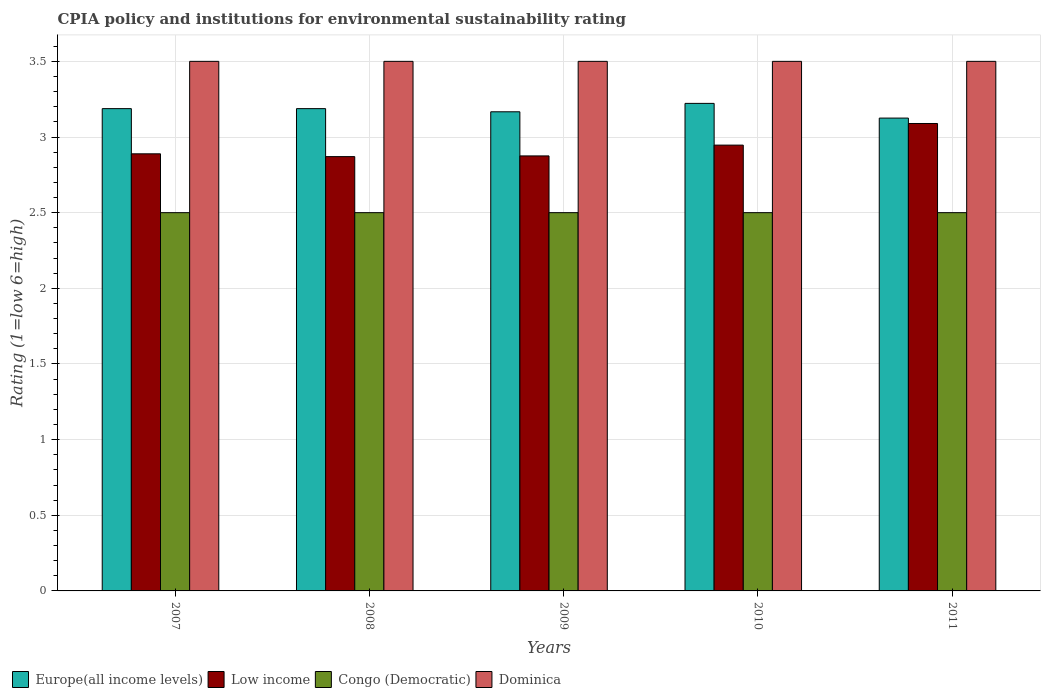How many different coloured bars are there?
Your answer should be very brief. 4. How many bars are there on the 2nd tick from the left?
Keep it short and to the point. 4. Across all years, what is the maximum CPIA rating in Low income?
Make the answer very short. 3.09. Across all years, what is the minimum CPIA rating in Europe(all income levels)?
Your answer should be very brief. 3.12. In which year was the CPIA rating in Europe(all income levels) maximum?
Make the answer very short. 2010. What is the total CPIA rating in Low income in the graph?
Make the answer very short. 14.67. What is the difference between the CPIA rating in Low income in 2007 and that in 2008?
Keep it short and to the point. 0.02. What is the difference between the CPIA rating in Europe(all income levels) in 2008 and the CPIA rating in Congo (Democratic) in 2010?
Your response must be concise. 0.69. What is the average CPIA rating in Congo (Democratic) per year?
Provide a succinct answer. 2.5. In the year 2009, what is the difference between the CPIA rating in Europe(all income levels) and CPIA rating in Dominica?
Give a very brief answer. -0.33. In how many years, is the CPIA rating in Congo (Democratic) greater than 0.6?
Offer a very short reply. 5. What is the ratio of the CPIA rating in Low income in 2008 to that in 2010?
Provide a succinct answer. 0.97. Is the difference between the CPIA rating in Europe(all income levels) in 2010 and 2011 greater than the difference between the CPIA rating in Dominica in 2010 and 2011?
Provide a short and direct response. Yes. What is the difference between the highest and the second highest CPIA rating in Congo (Democratic)?
Offer a very short reply. 0. In how many years, is the CPIA rating in Low income greater than the average CPIA rating in Low income taken over all years?
Give a very brief answer. 2. Is it the case that in every year, the sum of the CPIA rating in Congo (Democratic) and CPIA rating in Dominica is greater than the sum of CPIA rating in Europe(all income levels) and CPIA rating in Low income?
Your answer should be compact. No. What does the 1st bar from the left in 2007 represents?
Keep it short and to the point. Europe(all income levels). What does the 1st bar from the right in 2007 represents?
Provide a short and direct response. Dominica. How many years are there in the graph?
Make the answer very short. 5. What is the difference between two consecutive major ticks on the Y-axis?
Keep it short and to the point. 0.5. Does the graph contain grids?
Your answer should be very brief. Yes. Where does the legend appear in the graph?
Keep it short and to the point. Bottom left. How many legend labels are there?
Give a very brief answer. 4. What is the title of the graph?
Make the answer very short. CPIA policy and institutions for environmental sustainability rating. Does "Sierra Leone" appear as one of the legend labels in the graph?
Your answer should be compact. No. What is the label or title of the X-axis?
Offer a terse response. Years. What is the label or title of the Y-axis?
Give a very brief answer. Rating (1=low 6=high). What is the Rating (1=low 6=high) in Europe(all income levels) in 2007?
Keep it short and to the point. 3.19. What is the Rating (1=low 6=high) of Low income in 2007?
Your response must be concise. 2.89. What is the Rating (1=low 6=high) of Congo (Democratic) in 2007?
Provide a succinct answer. 2.5. What is the Rating (1=low 6=high) in Europe(all income levels) in 2008?
Ensure brevity in your answer.  3.19. What is the Rating (1=low 6=high) of Low income in 2008?
Make the answer very short. 2.87. What is the Rating (1=low 6=high) in Congo (Democratic) in 2008?
Your answer should be very brief. 2.5. What is the Rating (1=low 6=high) of Europe(all income levels) in 2009?
Provide a short and direct response. 3.17. What is the Rating (1=low 6=high) in Low income in 2009?
Give a very brief answer. 2.88. What is the Rating (1=low 6=high) in Dominica in 2009?
Your response must be concise. 3.5. What is the Rating (1=low 6=high) in Europe(all income levels) in 2010?
Your response must be concise. 3.22. What is the Rating (1=low 6=high) of Low income in 2010?
Your response must be concise. 2.95. What is the Rating (1=low 6=high) in Europe(all income levels) in 2011?
Make the answer very short. 3.12. What is the Rating (1=low 6=high) in Low income in 2011?
Give a very brief answer. 3.09. Across all years, what is the maximum Rating (1=low 6=high) of Europe(all income levels)?
Give a very brief answer. 3.22. Across all years, what is the maximum Rating (1=low 6=high) of Low income?
Keep it short and to the point. 3.09. Across all years, what is the maximum Rating (1=low 6=high) of Congo (Democratic)?
Make the answer very short. 2.5. Across all years, what is the minimum Rating (1=low 6=high) of Europe(all income levels)?
Your response must be concise. 3.12. Across all years, what is the minimum Rating (1=low 6=high) of Low income?
Your answer should be very brief. 2.87. Across all years, what is the minimum Rating (1=low 6=high) of Congo (Democratic)?
Your answer should be compact. 2.5. Across all years, what is the minimum Rating (1=low 6=high) in Dominica?
Provide a short and direct response. 3.5. What is the total Rating (1=low 6=high) in Europe(all income levels) in the graph?
Offer a terse response. 15.89. What is the total Rating (1=low 6=high) in Low income in the graph?
Your answer should be compact. 14.67. What is the difference between the Rating (1=low 6=high) in Low income in 2007 and that in 2008?
Provide a succinct answer. 0.02. What is the difference between the Rating (1=low 6=high) in Europe(all income levels) in 2007 and that in 2009?
Ensure brevity in your answer.  0.02. What is the difference between the Rating (1=low 6=high) of Low income in 2007 and that in 2009?
Your answer should be compact. 0.01. What is the difference between the Rating (1=low 6=high) in Congo (Democratic) in 2007 and that in 2009?
Ensure brevity in your answer.  0. What is the difference between the Rating (1=low 6=high) of Europe(all income levels) in 2007 and that in 2010?
Give a very brief answer. -0.03. What is the difference between the Rating (1=low 6=high) in Low income in 2007 and that in 2010?
Offer a very short reply. -0.06. What is the difference between the Rating (1=low 6=high) in Dominica in 2007 and that in 2010?
Offer a very short reply. 0. What is the difference between the Rating (1=low 6=high) of Europe(all income levels) in 2007 and that in 2011?
Offer a terse response. 0.06. What is the difference between the Rating (1=low 6=high) in Low income in 2007 and that in 2011?
Your answer should be very brief. -0.2. What is the difference between the Rating (1=low 6=high) of Europe(all income levels) in 2008 and that in 2009?
Provide a short and direct response. 0.02. What is the difference between the Rating (1=low 6=high) in Low income in 2008 and that in 2009?
Provide a succinct answer. -0. What is the difference between the Rating (1=low 6=high) in Dominica in 2008 and that in 2009?
Provide a succinct answer. 0. What is the difference between the Rating (1=low 6=high) of Europe(all income levels) in 2008 and that in 2010?
Keep it short and to the point. -0.03. What is the difference between the Rating (1=low 6=high) in Low income in 2008 and that in 2010?
Keep it short and to the point. -0.08. What is the difference between the Rating (1=low 6=high) of Congo (Democratic) in 2008 and that in 2010?
Give a very brief answer. 0. What is the difference between the Rating (1=low 6=high) of Dominica in 2008 and that in 2010?
Make the answer very short. 0. What is the difference between the Rating (1=low 6=high) in Europe(all income levels) in 2008 and that in 2011?
Ensure brevity in your answer.  0.06. What is the difference between the Rating (1=low 6=high) in Low income in 2008 and that in 2011?
Provide a succinct answer. -0.22. What is the difference between the Rating (1=low 6=high) in Dominica in 2008 and that in 2011?
Your answer should be compact. 0. What is the difference between the Rating (1=low 6=high) of Europe(all income levels) in 2009 and that in 2010?
Your answer should be very brief. -0.06. What is the difference between the Rating (1=low 6=high) of Low income in 2009 and that in 2010?
Offer a very short reply. -0.07. What is the difference between the Rating (1=low 6=high) in Europe(all income levels) in 2009 and that in 2011?
Your answer should be compact. 0.04. What is the difference between the Rating (1=low 6=high) of Low income in 2009 and that in 2011?
Give a very brief answer. -0.21. What is the difference between the Rating (1=low 6=high) of Dominica in 2009 and that in 2011?
Make the answer very short. 0. What is the difference between the Rating (1=low 6=high) of Europe(all income levels) in 2010 and that in 2011?
Ensure brevity in your answer.  0.1. What is the difference between the Rating (1=low 6=high) in Low income in 2010 and that in 2011?
Keep it short and to the point. -0.14. What is the difference between the Rating (1=low 6=high) in Congo (Democratic) in 2010 and that in 2011?
Keep it short and to the point. 0. What is the difference between the Rating (1=low 6=high) of Dominica in 2010 and that in 2011?
Provide a short and direct response. 0. What is the difference between the Rating (1=low 6=high) in Europe(all income levels) in 2007 and the Rating (1=low 6=high) in Low income in 2008?
Provide a short and direct response. 0.32. What is the difference between the Rating (1=low 6=high) in Europe(all income levels) in 2007 and the Rating (1=low 6=high) in Congo (Democratic) in 2008?
Offer a very short reply. 0.69. What is the difference between the Rating (1=low 6=high) of Europe(all income levels) in 2007 and the Rating (1=low 6=high) of Dominica in 2008?
Your response must be concise. -0.31. What is the difference between the Rating (1=low 6=high) of Low income in 2007 and the Rating (1=low 6=high) of Congo (Democratic) in 2008?
Your answer should be very brief. 0.39. What is the difference between the Rating (1=low 6=high) of Low income in 2007 and the Rating (1=low 6=high) of Dominica in 2008?
Your response must be concise. -0.61. What is the difference between the Rating (1=low 6=high) in Europe(all income levels) in 2007 and the Rating (1=low 6=high) in Low income in 2009?
Provide a succinct answer. 0.31. What is the difference between the Rating (1=low 6=high) in Europe(all income levels) in 2007 and the Rating (1=low 6=high) in Congo (Democratic) in 2009?
Your answer should be very brief. 0.69. What is the difference between the Rating (1=low 6=high) in Europe(all income levels) in 2007 and the Rating (1=low 6=high) in Dominica in 2009?
Your answer should be compact. -0.31. What is the difference between the Rating (1=low 6=high) of Low income in 2007 and the Rating (1=low 6=high) of Congo (Democratic) in 2009?
Provide a succinct answer. 0.39. What is the difference between the Rating (1=low 6=high) in Low income in 2007 and the Rating (1=low 6=high) in Dominica in 2009?
Ensure brevity in your answer.  -0.61. What is the difference between the Rating (1=low 6=high) in Congo (Democratic) in 2007 and the Rating (1=low 6=high) in Dominica in 2009?
Give a very brief answer. -1. What is the difference between the Rating (1=low 6=high) of Europe(all income levels) in 2007 and the Rating (1=low 6=high) of Low income in 2010?
Offer a very short reply. 0.24. What is the difference between the Rating (1=low 6=high) of Europe(all income levels) in 2007 and the Rating (1=low 6=high) of Congo (Democratic) in 2010?
Ensure brevity in your answer.  0.69. What is the difference between the Rating (1=low 6=high) in Europe(all income levels) in 2007 and the Rating (1=low 6=high) in Dominica in 2010?
Ensure brevity in your answer.  -0.31. What is the difference between the Rating (1=low 6=high) in Low income in 2007 and the Rating (1=low 6=high) in Congo (Democratic) in 2010?
Offer a very short reply. 0.39. What is the difference between the Rating (1=low 6=high) of Low income in 2007 and the Rating (1=low 6=high) of Dominica in 2010?
Offer a terse response. -0.61. What is the difference between the Rating (1=low 6=high) in Europe(all income levels) in 2007 and the Rating (1=low 6=high) in Low income in 2011?
Give a very brief answer. 0.1. What is the difference between the Rating (1=low 6=high) of Europe(all income levels) in 2007 and the Rating (1=low 6=high) of Congo (Democratic) in 2011?
Provide a short and direct response. 0.69. What is the difference between the Rating (1=low 6=high) of Europe(all income levels) in 2007 and the Rating (1=low 6=high) of Dominica in 2011?
Give a very brief answer. -0.31. What is the difference between the Rating (1=low 6=high) of Low income in 2007 and the Rating (1=low 6=high) of Congo (Democratic) in 2011?
Your answer should be compact. 0.39. What is the difference between the Rating (1=low 6=high) of Low income in 2007 and the Rating (1=low 6=high) of Dominica in 2011?
Provide a succinct answer. -0.61. What is the difference between the Rating (1=low 6=high) in Europe(all income levels) in 2008 and the Rating (1=low 6=high) in Low income in 2009?
Offer a terse response. 0.31. What is the difference between the Rating (1=low 6=high) of Europe(all income levels) in 2008 and the Rating (1=low 6=high) of Congo (Democratic) in 2009?
Offer a terse response. 0.69. What is the difference between the Rating (1=low 6=high) in Europe(all income levels) in 2008 and the Rating (1=low 6=high) in Dominica in 2009?
Your response must be concise. -0.31. What is the difference between the Rating (1=low 6=high) in Low income in 2008 and the Rating (1=low 6=high) in Congo (Democratic) in 2009?
Ensure brevity in your answer.  0.37. What is the difference between the Rating (1=low 6=high) in Low income in 2008 and the Rating (1=low 6=high) in Dominica in 2009?
Offer a very short reply. -0.63. What is the difference between the Rating (1=low 6=high) in Congo (Democratic) in 2008 and the Rating (1=low 6=high) in Dominica in 2009?
Give a very brief answer. -1. What is the difference between the Rating (1=low 6=high) in Europe(all income levels) in 2008 and the Rating (1=low 6=high) in Low income in 2010?
Offer a terse response. 0.24. What is the difference between the Rating (1=low 6=high) in Europe(all income levels) in 2008 and the Rating (1=low 6=high) in Congo (Democratic) in 2010?
Your answer should be very brief. 0.69. What is the difference between the Rating (1=low 6=high) in Europe(all income levels) in 2008 and the Rating (1=low 6=high) in Dominica in 2010?
Give a very brief answer. -0.31. What is the difference between the Rating (1=low 6=high) in Low income in 2008 and the Rating (1=low 6=high) in Congo (Democratic) in 2010?
Your answer should be compact. 0.37. What is the difference between the Rating (1=low 6=high) in Low income in 2008 and the Rating (1=low 6=high) in Dominica in 2010?
Make the answer very short. -0.63. What is the difference between the Rating (1=low 6=high) of Congo (Democratic) in 2008 and the Rating (1=low 6=high) of Dominica in 2010?
Make the answer very short. -1. What is the difference between the Rating (1=low 6=high) of Europe(all income levels) in 2008 and the Rating (1=low 6=high) of Low income in 2011?
Your response must be concise. 0.1. What is the difference between the Rating (1=low 6=high) of Europe(all income levels) in 2008 and the Rating (1=low 6=high) of Congo (Democratic) in 2011?
Your response must be concise. 0.69. What is the difference between the Rating (1=low 6=high) in Europe(all income levels) in 2008 and the Rating (1=low 6=high) in Dominica in 2011?
Offer a terse response. -0.31. What is the difference between the Rating (1=low 6=high) of Low income in 2008 and the Rating (1=low 6=high) of Congo (Democratic) in 2011?
Offer a terse response. 0.37. What is the difference between the Rating (1=low 6=high) of Low income in 2008 and the Rating (1=low 6=high) of Dominica in 2011?
Your response must be concise. -0.63. What is the difference between the Rating (1=low 6=high) of Congo (Democratic) in 2008 and the Rating (1=low 6=high) of Dominica in 2011?
Your answer should be very brief. -1. What is the difference between the Rating (1=low 6=high) in Europe(all income levels) in 2009 and the Rating (1=low 6=high) in Low income in 2010?
Your response must be concise. 0.22. What is the difference between the Rating (1=low 6=high) in Europe(all income levels) in 2009 and the Rating (1=low 6=high) in Congo (Democratic) in 2010?
Provide a succinct answer. 0.67. What is the difference between the Rating (1=low 6=high) in Europe(all income levels) in 2009 and the Rating (1=low 6=high) in Dominica in 2010?
Your response must be concise. -0.33. What is the difference between the Rating (1=low 6=high) in Low income in 2009 and the Rating (1=low 6=high) in Dominica in 2010?
Ensure brevity in your answer.  -0.62. What is the difference between the Rating (1=low 6=high) in Europe(all income levels) in 2009 and the Rating (1=low 6=high) in Low income in 2011?
Offer a very short reply. 0.08. What is the difference between the Rating (1=low 6=high) of Europe(all income levels) in 2009 and the Rating (1=low 6=high) of Dominica in 2011?
Give a very brief answer. -0.33. What is the difference between the Rating (1=low 6=high) in Low income in 2009 and the Rating (1=low 6=high) in Congo (Democratic) in 2011?
Give a very brief answer. 0.38. What is the difference between the Rating (1=low 6=high) in Low income in 2009 and the Rating (1=low 6=high) in Dominica in 2011?
Your answer should be very brief. -0.62. What is the difference between the Rating (1=low 6=high) of Europe(all income levels) in 2010 and the Rating (1=low 6=high) of Low income in 2011?
Offer a very short reply. 0.13. What is the difference between the Rating (1=low 6=high) of Europe(all income levels) in 2010 and the Rating (1=low 6=high) of Congo (Democratic) in 2011?
Keep it short and to the point. 0.72. What is the difference between the Rating (1=low 6=high) of Europe(all income levels) in 2010 and the Rating (1=low 6=high) of Dominica in 2011?
Your response must be concise. -0.28. What is the difference between the Rating (1=low 6=high) of Low income in 2010 and the Rating (1=low 6=high) of Congo (Democratic) in 2011?
Your answer should be very brief. 0.45. What is the difference between the Rating (1=low 6=high) of Low income in 2010 and the Rating (1=low 6=high) of Dominica in 2011?
Your answer should be compact. -0.55. What is the average Rating (1=low 6=high) in Europe(all income levels) per year?
Offer a very short reply. 3.18. What is the average Rating (1=low 6=high) in Low income per year?
Your response must be concise. 2.93. In the year 2007, what is the difference between the Rating (1=low 6=high) in Europe(all income levels) and Rating (1=low 6=high) in Low income?
Provide a short and direct response. 0.3. In the year 2007, what is the difference between the Rating (1=low 6=high) in Europe(all income levels) and Rating (1=low 6=high) in Congo (Democratic)?
Your response must be concise. 0.69. In the year 2007, what is the difference between the Rating (1=low 6=high) of Europe(all income levels) and Rating (1=low 6=high) of Dominica?
Your answer should be compact. -0.31. In the year 2007, what is the difference between the Rating (1=low 6=high) of Low income and Rating (1=low 6=high) of Congo (Democratic)?
Ensure brevity in your answer.  0.39. In the year 2007, what is the difference between the Rating (1=low 6=high) of Low income and Rating (1=low 6=high) of Dominica?
Make the answer very short. -0.61. In the year 2007, what is the difference between the Rating (1=low 6=high) of Congo (Democratic) and Rating (1=low 6=high) of Dominica?
Offer a very short reply. -1. In the year 2008, what is the difference between the Rating (1=low 6=high) in Europe(all income levels) and Rating (1=low 6=high) in Low income?
Provide a succinct answer. 0.32. In the year 2008, what is the difference between the Rating (1=low 6=high) in Europe(all income levels) and Rating (1=low 6=high) in Congo (Democratic)?
Your answer should be compact. 0.69. In the year 2008, what is the difference between the Rating (1=low 6=high) of Europe(all income levels) and Rating (1=low 6=high) of Dominica?
Your answer should be very brief. -0.31. In the year 2008, what is the difference between the Rating (1=low 6=high) in Low income and Rating (1=low 6=high) in Congo (Democratic)?
Ensure brevity in your answer.  0.37. In the year 2008, what is the difference between the Rating (1=low 6=high) of Low income and Rating (1=low 6=high) of Dominica?
Your answer should be compact. -0.63. In the year 2008, what is the difference between the Rating (1=low 6=high) of Congo (Democratic) and Rating (1=low 6=high) of Dominica?
Offer a terse response. -1. In the year 2009, what is the difference between the Rating (1=low 6=high) of Europe(all income levels) and Rating (1=low 6=high) of Low income?
Keep it short and to the point. 0.29. In the year 2009, what is the difference between the Rating (1=low 6=high) of Europe(all income levels) and Rating (1=low 6=high) of Congo (Democratic)?
Keep it short and to the point. 0.67. In the year 2009, what is the difference between the Rating (1=low 6=high) of Europe(all income levels) and Rating (1=low 6=high) of Dominica?
Offer a very short reply. -0.33. In the year 2009, what is the difference between the Rating (1=low 6=high) in Low income and Rating (1=low 6=high) in Dominica?
Your answer should be compact. -0.62. In the year 2009, what is the difference between the Rating (1=low 6=high) in Congo (Democratic) and Rating (1=low 6=high) in Dominica?
Your answer should be compact. -1. In the year 2010, what is the difference between the Rating (1=low 6=high) in Europe(all income levels) and Rating (1=low 6=high) in Low income?
Offer a terse response. 0.28. In the year 2010, what is the difference between the Rating (1=low 6=high) of Europe(all income levels) and Rating (1=low 6=high) of Congo (Democratic)?
Your answer should be very brief. 0.72. In the year 2010, what is the difference between the Rating (1=low 6=high) of Europe(all income levels) and Rating (1=low 6=high) of Dominica?
Make the answer very short. -0.28. In the year 2010, what is the difference between the Rating (1=low 6=high) in Low income and Rating (1=low 6=high) in Congo (Democratic)?
Keep it short and to the point. 0.45. In the year 2010, what is the difference between the Rating (1=low 6=high) in Low income and Rating (1=low 6=high) in Dominica?
Provide a short and direct response. -0.55. In the year 2011, what is the difference between the Rating (1=low 6=high) of Europe(all income levels) and Rating (1=low 6=high) of Low income?
Keep it short and to the point. 0.04. In the year 2011, what is the difference between the Rating (1=low 6=high) in Europe(all income levels) and Rating (1=low 6=high) in Dominica?
Provide a succinct answer. -0.38. In the year 2011, what is the difference between the Rating (1=low 6=high) of Low income and Rating (1=low 6=high) of Congo (Democratic)?
Your answer should be compact. 0.59. In the year 2011, what is the difference between the Rating (1=low 6=high) of Low income and Rating (1=low 6=high) of Dominica?
Make the answer very short. -0.41. In the year 2011, what is the difference between the Rating (1=low 6=high) of Congo (Democratic) and Rating (1=low 6=high) of Dominica?
Provide a short and direct response. -1. What is the ratio of the Rating (1=low 6=high) of Europe(all income levels) in 2007 to that in 2008?
Offer a terse response. 1. What is the ratio of the Rating (1=low 6=high) in Low income in 2007 to that in 2008?
Make the answer very short. 1.01. What is the ratio of the Rating (1=low 6=high) in Congo (Democratic) in 2007 to that in 2008?
Keep it short and to the point. 1. What is the ratio of the Rating (1=low 6=high) in Dominica in 2007 to that in 2008?
Give a very brief answer. 1. What is the ratio of the Rating (1=low 6=high) of Europe(all income levels) in 2007 to that in 2009?
Offer a very short reply. 1.01. What is the ratio of the Rating (1=low 6=high) in Low income in 2007 to that in 2009?
Offer a very short reply. 1. What is the ratio of the Rating (1=low 6=high) in Congo (Democratic) in 2007 to that in 2009?
Give a very brief answer. 1. What is the ratio of the Rating (1=low 6=high) of Europe(all income levels) in 2007 to that in 2010?
Give a very brief answer. 0.99. What is the ratio of the Rating (1=low 6=high) of Low income in 2007 to that in 2010?
Your answer should be compact. 0.98. What is the ratio of the Rating (1=low 6=high) in Congo (Democratic) in 2007 to that in 2010?
Your answer should be compact. 1. What is the ratio of the Rating (1=low 6=high) in Low income in 2007 to that in 2011?
Offer a very short reply. 0.94. What is the ratio of the Rating (1=low 6=high) in Europe(all income levels) in 2008 to that in 2009?
Provide a succinct answer. 1.01. What is the ratio of the Rating (1=low 6=high) in Congo (Democratic) in 2008 to that in 2009?
Your answer should be very brief. 1. What is the ratio of the Rating (1=low 6=high) of Europe(all income levels) in 2008 to that in 2010?
Ensure brevity in your answer.  0.99. What is the ratio of the Rating (1=low 6=high) of Low income in 2008 to that in 2010?
Give a very brief answer. 0.97. What is the ratio of the Rating (1=low 6=high) in Dominica in 2008 to that in 2010?
Ensure brevity in your answer.  1. What is the ratio of the Rating (1=low 6=high) in Low income in 2008 to that in 2011?
Ensure brevity in your answer.  0.93. What is the ratio of the Rating (1=low 6=high) of Congo (Democratic) in 2008 to that in 2011?
Keep it short and to the point. 1. What is the ratio of the Rating (1=low 6=high) of Europe(all income levels) in 2009 to that in 2010?
Your answer should be compact. 0.98. What is the ratio of the Rating (1=low 6=high) of Low income in 2009 to that in 2010?
Your response must be concise. 0.98. What is the ratio of the Rating (1=low 6=high) of Europe(all income levels) in 2009 to that in 2011?
Ensure brevity in your answer.  1.01. What is the ratio of the Rating (1=low 6=high) of Low income in 2009 to that in 2011?
Offer a very short reply. 0.93. What is the ratio of the Rating (1=low 6=high) in Congo (Democratic) in 2009 to that in 2011?
Your answer should be compact. 1. What is the ratio of the Rating (1=low 6=high) in Dominica in 2009 to that in 2011?
Your answer should be compact. 1. What is the ratio of the Rating (1=low 6=high) of Europe(all income levels) in 2010 to that in 2011?
Make the answer very short. 1.03. What is the ratio of the Rating (1=low 6=high) of Low income in 2010 to that in 2011?
Provide a succinct answer. 0.95. What is the ratio of the Rating (1=low 6=high) of Congo (Democratic) in 2010 to that in 2011?
Give a very brief answer. 1. What is the difference between the highest and the second highest Rating (1=low 6=high) of Europe(all income levels)?
Your answer should be very brief. 0.03. What is the difference between the highest and the second highest Rating (1=low 6=high) of Low income?
Your response must be concise. 0.14. What is the difference between the highest and the lowest Rating (1=low 6=high) in Europe(all income levels)?
Keep it short and to the point. 0.1. What is the difference between the highest and the lowest Rating (1=low 6=high) of Low income?
Provide a short and direct response. 0.22. What is the difference between the highest and the lowest Rating (1=low 6=high) in Dominica?
Your response must be concise. 0. 